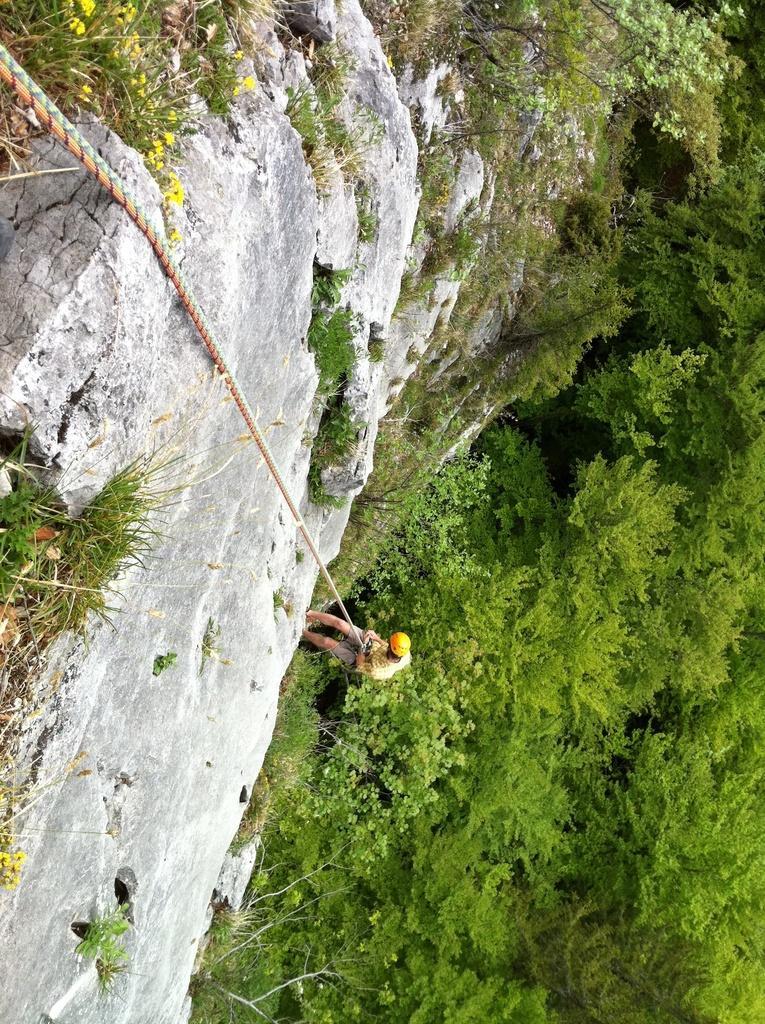In one or two sentences, can you explain what this image depicts? In this image there is a person holding the rope. He is climbing on the rock. Right side there are trees. There are trees and plants on the rock. 